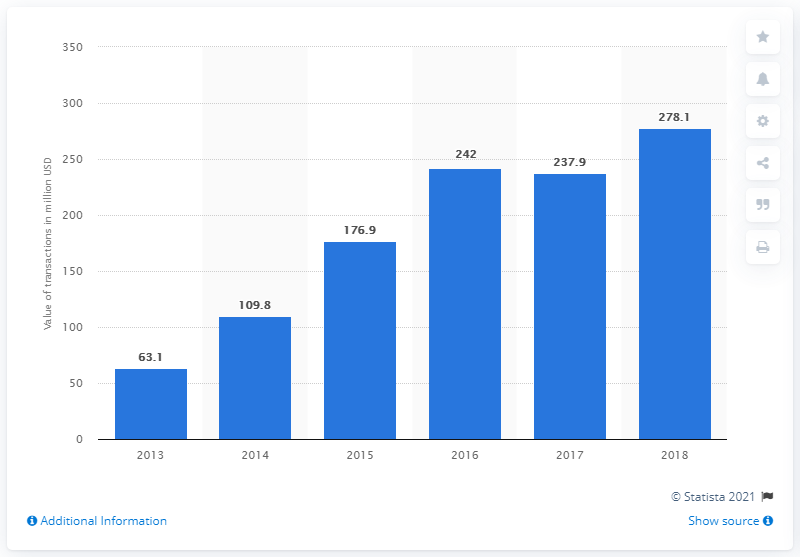List a handful of essential elements in this visual. In the United States in 2018, the total value of equity-based crowdfunding was 278.1 million dollars. 